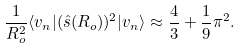Convert formula to latex. <formula><loc_0><loc_0><loc_500><loc_500>\frac { 1 } { R _ { o } ^ { 2 } } \langle v _ { n } | ( \hat { s } ( R _ { o } ) ) ^ { 2 } | v _ { n } \rangle \approx \frac { 4 } { 3 } + \frac { 1 } { 9 } \pi ^ { 2 } .</formula> 